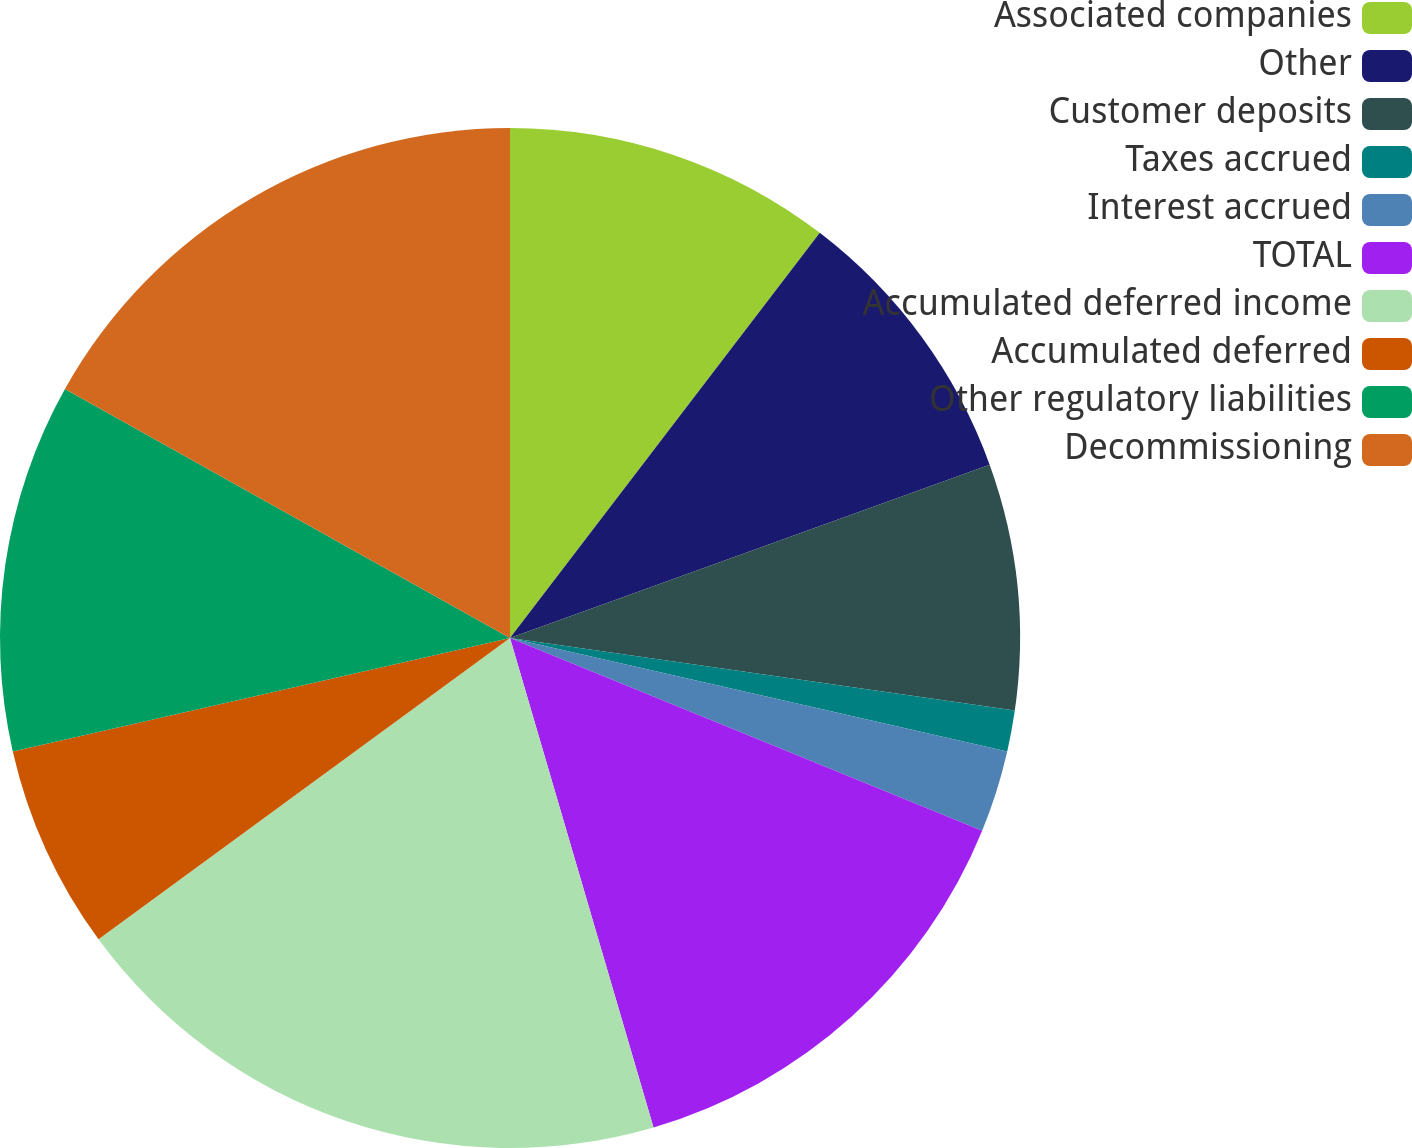Convert chart. <chart><loc_0><loc_0><loc_500><loc_500><pie_chart><fcel>Associated companies<fcel>Other<fcel>Customer deposits<fcel>Taxes accrued<fcel>Interest accrued<fcel>TOTAL<fcel>Accumulated deferred income<fcel>Accumulated deferred<fcel>Other regulatory liabilities<fcel>Decommissioning<nl><fcel>10.39%<fcel>9.09%<fcel>7.79%<fcel>1.3%<fcel>2.6%<fcel>14.29%<fcel>19.48%<fcel>6.49%<fcel>11.69%<fcel>16.88%<nl></chart> 